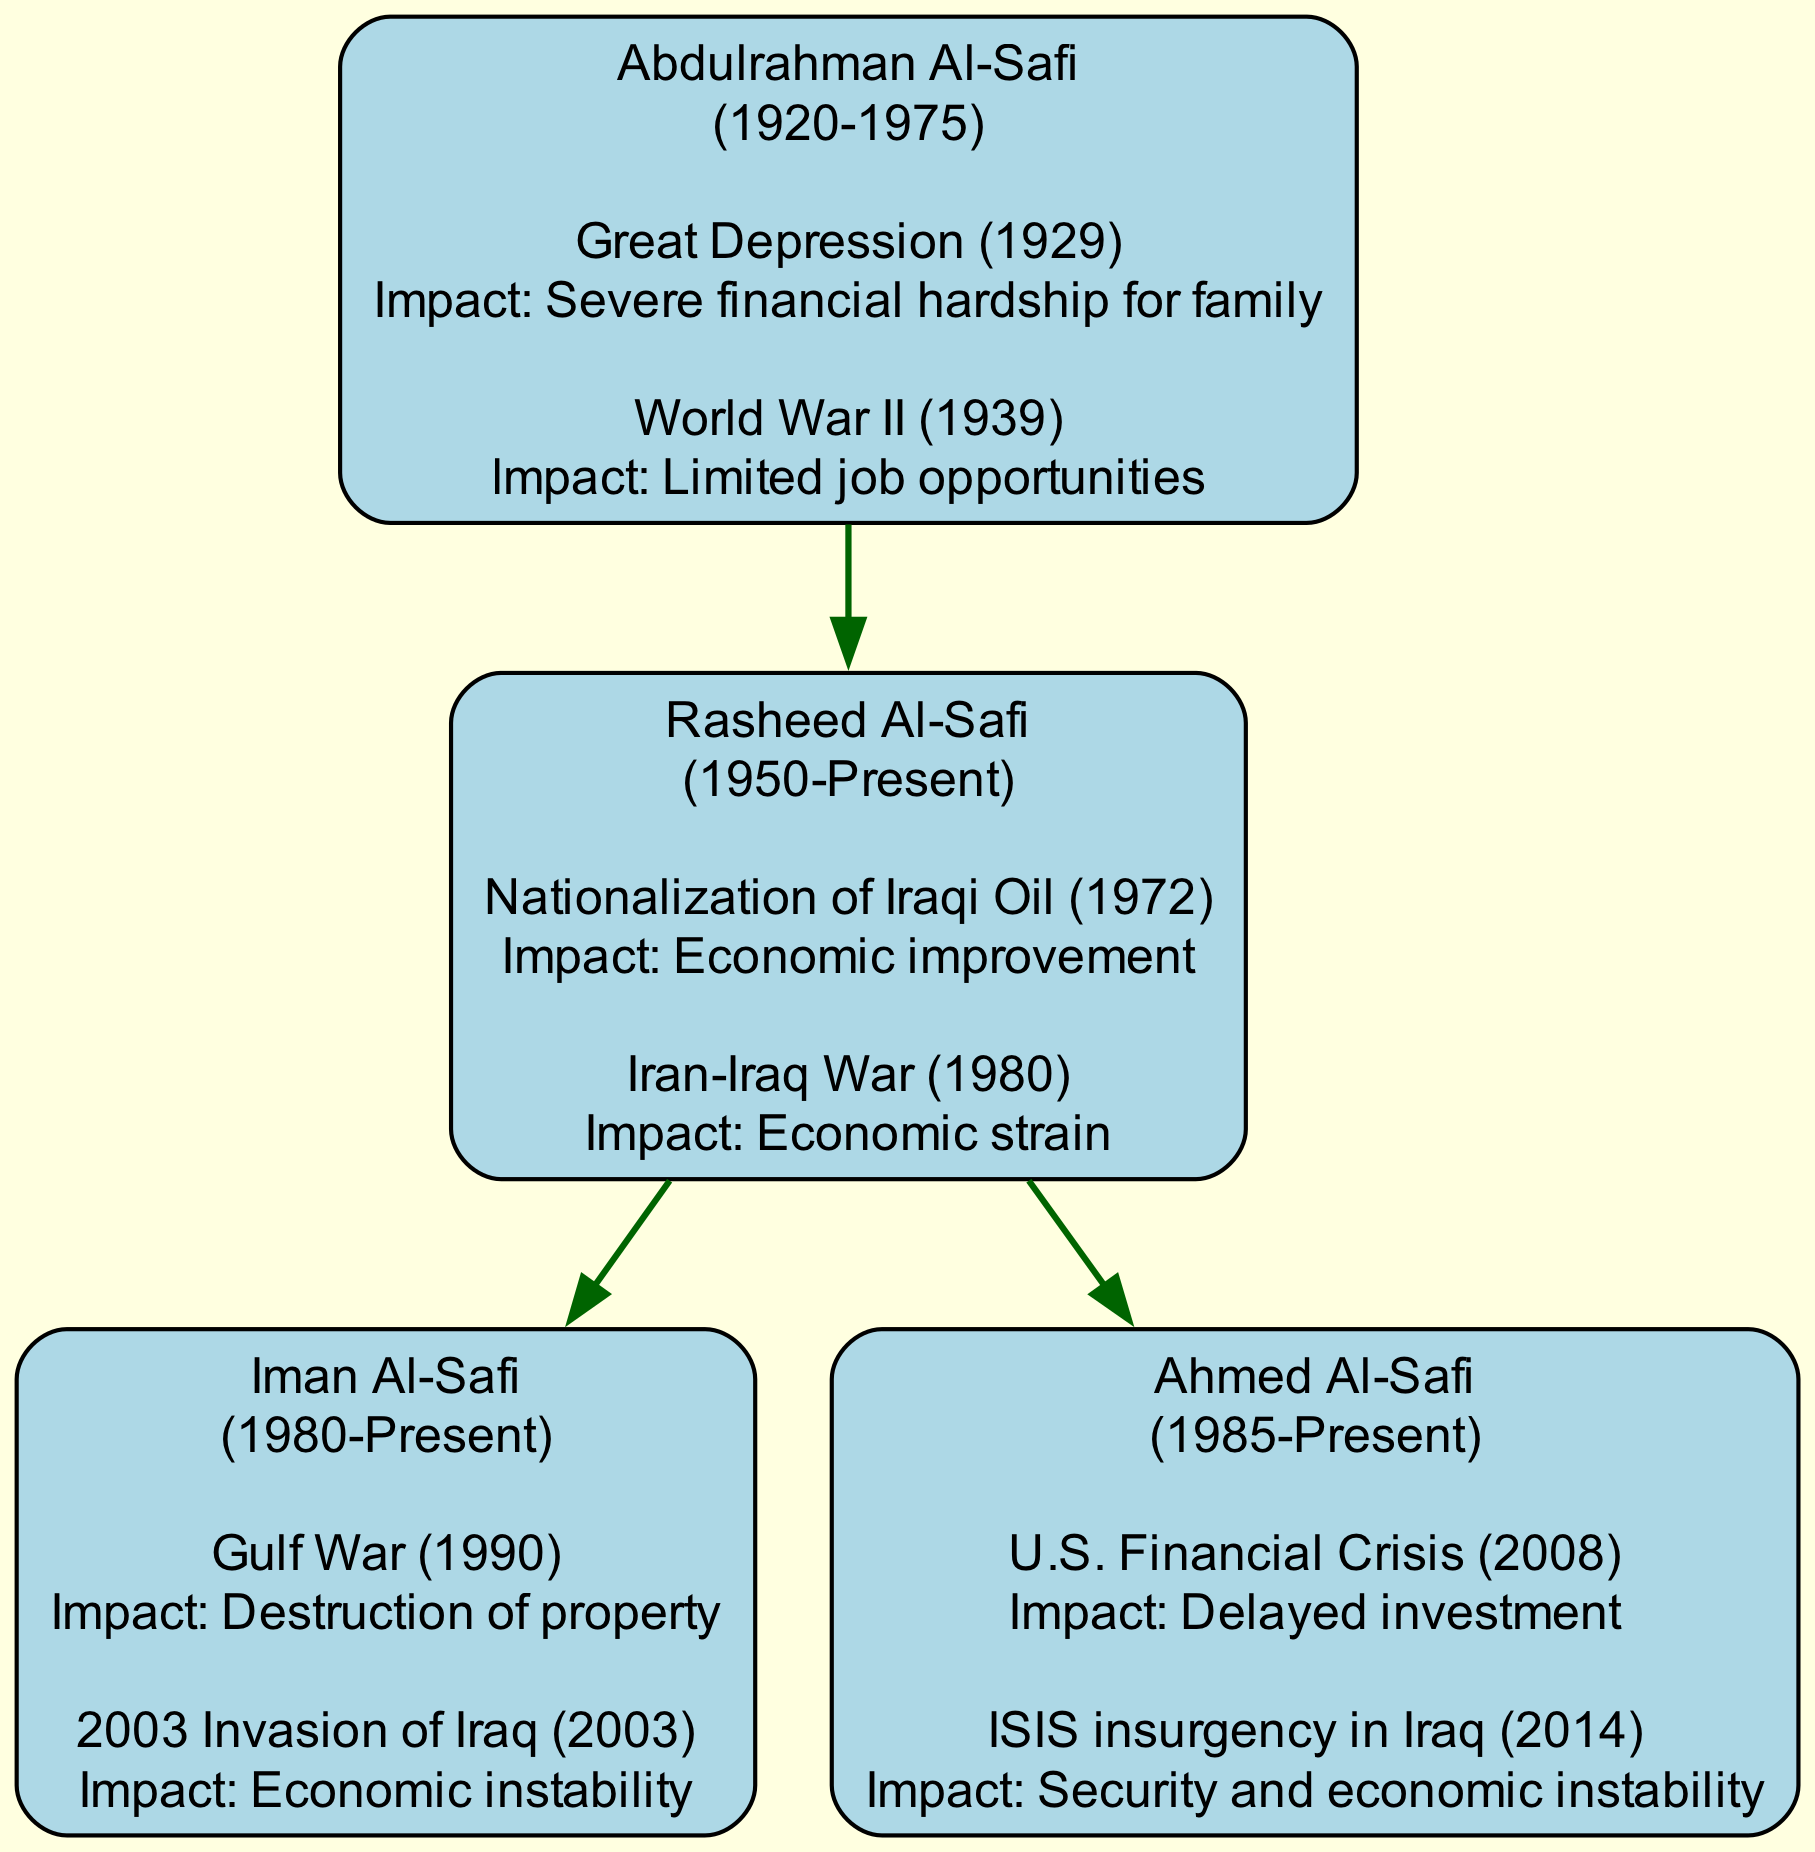What is the birth year of Abdulrahman Al-Safi? The birth year of Abdulrahman Al-Safi is explicitly mentioned in the diagram as 1920, directly linked to his node.
Answer: 1920 How many historical events are linked to Iman Al-Safi? By inspecting Iman Al-Safi's node, it notes two historical events beneath his name, indicating the count of events associated.
Answer: 2 What economic impact did the Gulf War have on Iman Al-Safi? The diagram states that the Gulf War led to "Destruction of property" affecting Iman Al-Safi, indicating the economic impact directly.
Answer: Destruction of property Who is the child of Rasheed Al-Safi? From the diagram, looking at Rasheed Al-Safi’s children, both Iman Al-Safi and Ahmed Al-Safi are listed, identifying them as his offspring.
Answer: Iman Al-Safi, Ahmed Al-Safi What significant event affected Rasheed Al-Safi in 1980? The node corresponding to Rasheed Al-Safi highlights the event "Iran-Iraq War" occurring in 1980, showing the direct correlation to his financial situation.
Answer: Iran-Iraq War How many total children does Abdulrahman Al-Safi have? By examining the node for Abdulrahman Al-Safi, there is only one child listed, Rasheed Al-Safi, leading to the conclusion of his total offspring count.
Answer: 1 Which historical event occurred in 2003 that impacted Ahmed Al-Safi? The node for Ahmed Al-Safi indicates the "2003 Invasion of Iraq" as a key event affecting him, directly stating the event's year and impact.
Answer: 2003 Invasion of Iraq What was the impact of the nationalization of Iraqi oil on Rasheed Al-Safi? The diagram specifies the "Economic improvement" linked to the nationalization event in 1972, showing the beneficial consequences for Rasheed Al-Safi.
Answer: Economic improvement Which family member was born in 1985? In the diagram, the node for a child shows that Ahmed Al-Safi’s birth year is mentioned as 1985, identifying him in the family lineage.
Answer: Ahmed Al-Safi 